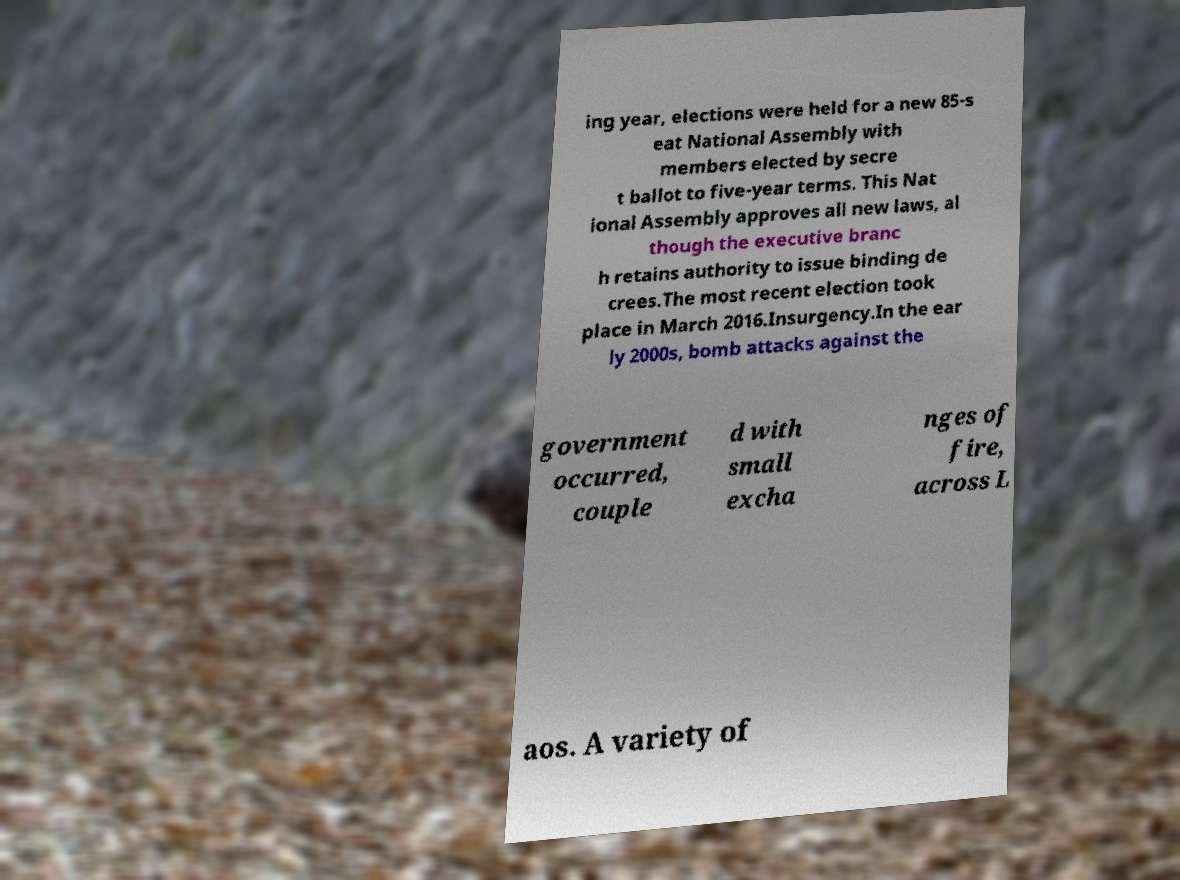Please identify and transcribe the text found in this image. ing year, elections were held for a new 85-s eat National Assembly with members elected by secre t ballot to five-year terms. This Nat ional Assembly approves all new laws, al though the executive branc h retains authority to issue binding de crees.The most recent election took place in March 2016.Insurgency.In the ear ly 2000s, bomb attacks against the government occurred, couple d with small excha nges of fire, across L aos. A variety of 